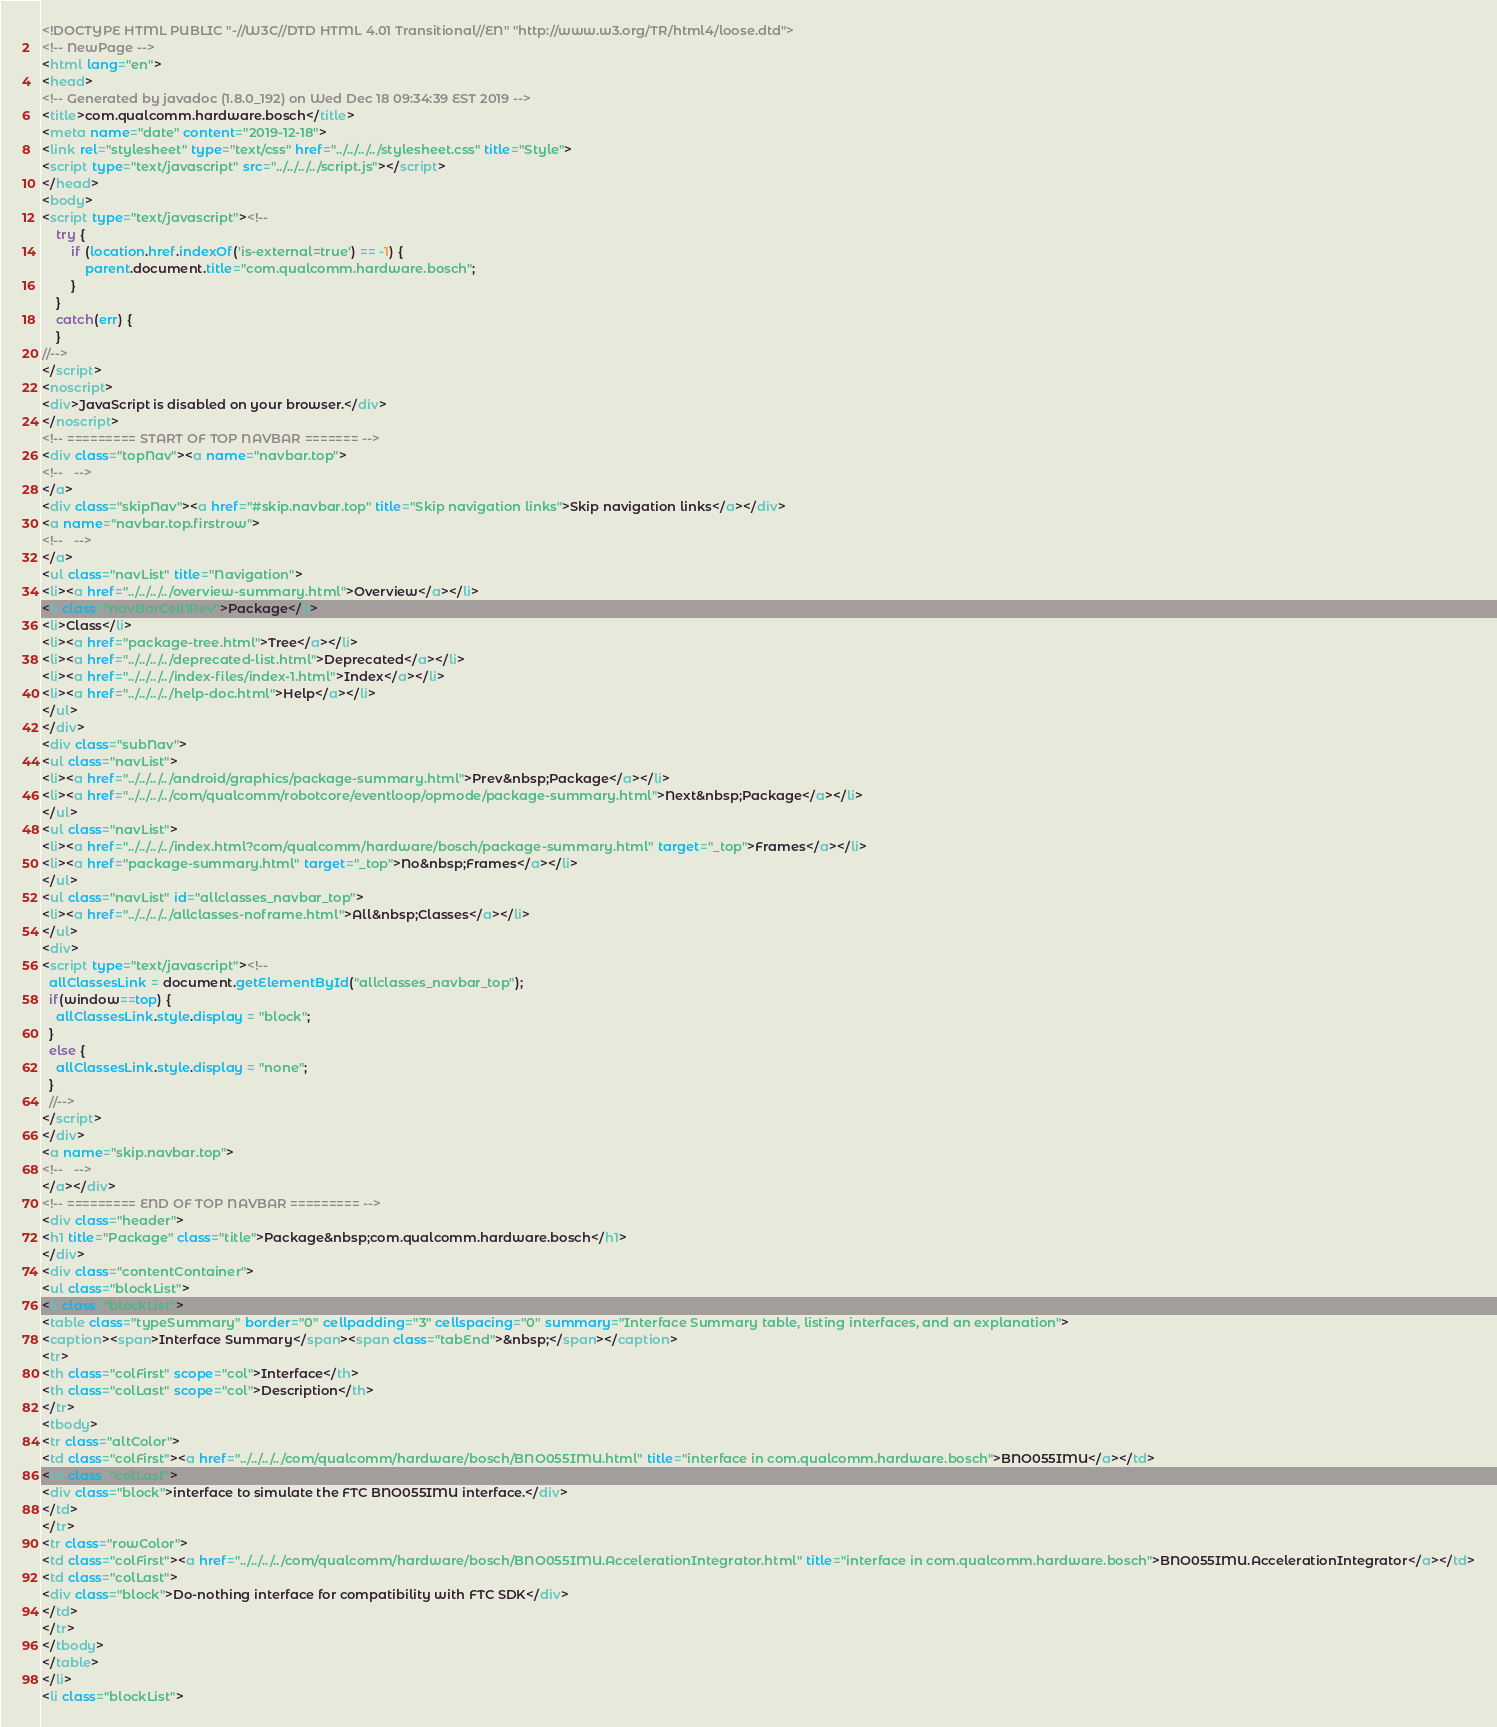<code> <loc_0><loc_0><loc_500><loc_500><_HTML_><!DOCTYPE HTML PUBLIC "-//W3C//DTD HTML 4.01 Transitional//EN" "http://www.w3.org/TR/html4/loose.dtd">
<!-- NewPage -->
<html lang="en">
<head>
<!-- Generated by javadoc (1.8.0_192) on Wed Dec 18 09:34:39 EST 2019 -->
<title>com.qualcomm.hardware.bosch</title>
<meta name="date" content="2019-12-18">
<link rel="stylesheet" type="text/css" href="../../../../stylesheet.css" title="Style">
<script type="text/javascript" src="../../../../script.js"></script>
</head>
<body>
<script type="text/javascript"><!--
    try {
        if (location.href.indexOf('is-external=true') == -1) {
            parent.document.title="com.qualcomm.hardware.bosch";
        }
    }
    catch(err) {
    }
//-->
</script>
<noscript>
<div>JavaScript is disabled on your browser.</div>
</noscript>
<!-- ========= START OF TOP NAVBAR ======= -->
<div class="topNav"><a name="navbar.top">
<!--   -->
</a>
<div class="skipNav"><a href="#skip.navbar.top" title="Skip navigation links">Skip navigation links</a></div>
<a name="navbar.top.firstrow">
<!--   -->
</a>
<ul class="navList" title="Navigation">
<li><a href="../../../../overview-summary.html">Overview</a></li>
<li class="navBarCell1Rev">Package</li>
<li>Class</li>
<li><a href="package-tree.html">Tree</a></li>
<li><a href="../../../../deprecated-list.html">Deprecated</a></li>
<li><a href="../../../../index-files/index-1.html">Index</a></li>
<li><a href="../../../../help-doc.html">Help</a></li>
</ul>
</div>
<div class="subNav">
<ul class="navList">
<li><a href="../../../../android/graphics/package-summary.html">Prev&nbsp;Package</a></li>
<li><a href="../../../../com/qualcomm/robotcore/eventloop/opmode/package-summary.html">Next&nbsp;Package</a></li>
</ul>
<ul class="navList">
<li><a href="../../../../index.html?com/qualcomm/hardware/bosch/package-summary.html" target="_top">Frames</a></li>
<li><a href="package-summary.html" target="_top">No&nbsp;Frames</a></li>
</ul>
<ul class="navList" id="allclasses_navbar_top">
<li><a href="../../../../allclasses-noframe.html">All&nbsp;Classes</a></li>
</ul>
<div>
<script type="text/javascript"><!--
  allClassesLink = document.getElementById("allclasses_navbar_top");
  if(window==top) {
    allClassesLink.style.display = "block";
  }
  else {
    allClassesLink.style.display = "none";
  }
  //-->
</script>
</div>
<a name="skip.navbar.top">
<!--   -->
</a></div>
<!-- ========= END OF TOP NAVBAR ========= -->
<div class="header">
<h1 title="Package" class="title">Package&nbsp;com.qualcomm.hardware.bosch</h1>
</div>
<div class="contentContainer">
<ul class="blockList">
<li class="blockList">
<table class="typeSummary" border="0" cellpadding="3" cellspacing="0" summary="Interface Summary table, listing interfaces, and an explanation">
<caption><span>Interface Summary</span><span class="tabEnd">&nbsp;</span></caption>
<tr>
<th class="colFirst" scope="col">Interface</th>
<th class="colLast" scope="col">Description</th>
</tr>
<tbody>
<tr class="altColor">
<td class="colFirst"><a href="../../../../com/qualcomm/hardware/bosch/BNO055IMU.html" title="interface in com.qualcomm.hardware.bosch">BNO055IMU</a></td>
<td class="colLast">
<div class="block">interface to simulate the FTC BNO055IMU interface.</div>
</td>
</tr>
<tr class="rowColor">
<td class="colFirst"><a href="../../../../com/qualcomm/hardware/bosch/BNO055IMU.AccelerationIntegrator.html" title="interface in com.qualcomm.hardware.bosch">BNO055IMU.AccelerationIntegrator</a></td>
<td class="colLast">
<div class="block">Do-nothing interface for compatibility with FTC SDK</div>
</td>
</tr>
</tbody>
</table>
</li>
<li class="blockList"></code> 